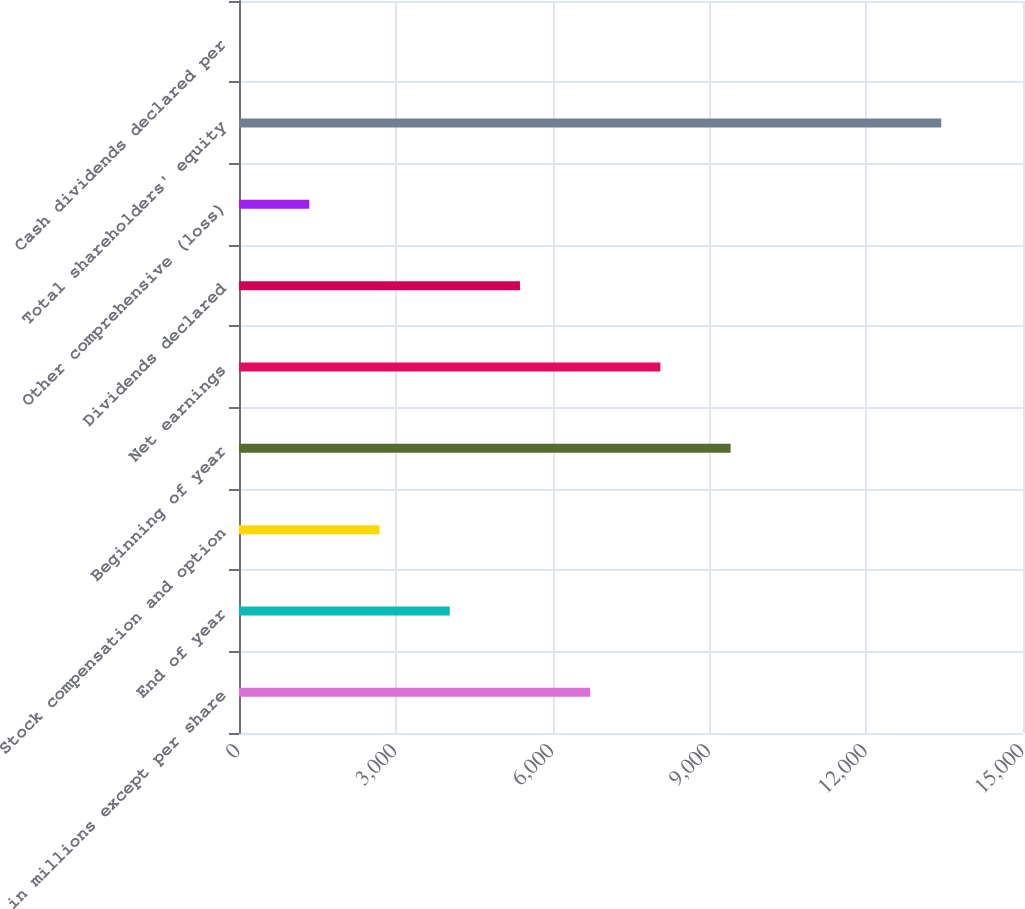Convert chart. <chart><loc_0><loc_0><loc_500><loc_500><bar_chart><fcel>in millions except per share<fcel>End of year<fcel>Stock compensation and option<fcel>Beginning of year<fcel>Net earnings<fcel>Dividends declared<fcel>Other comprehensive (loss)<fcel>Total shareholders' equity<fcel>Cash dividends declared per<nl><fcel>6718.94<fcel>4032.1<fcel>2688.68<fcel>9405.78<fcel>8062.36<fcel>5375.52<fcel>1345.26<fcel>13436<fcel>1.84<nl></chart> 